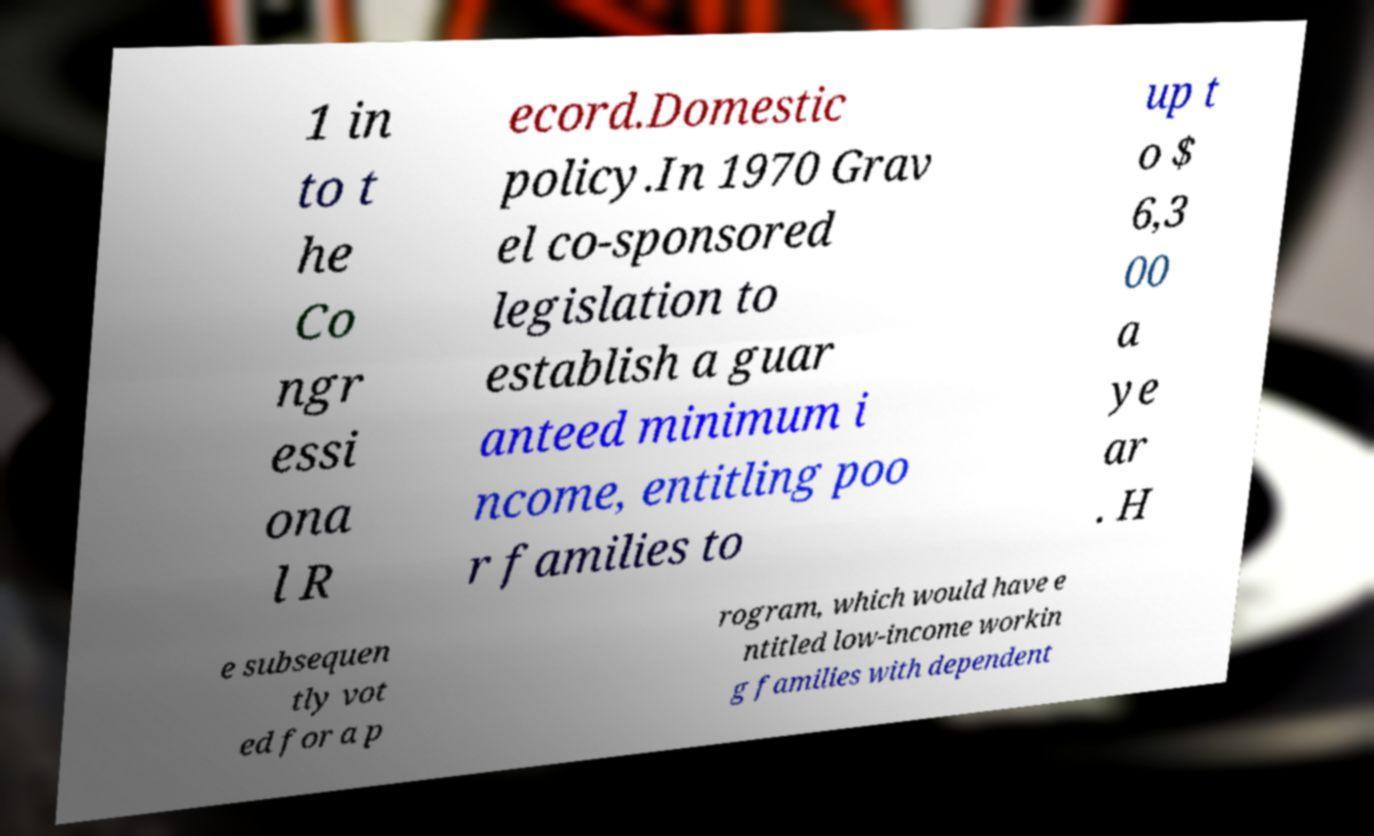Can you accurately transcribe the text from the provided image for me? 1 in to t he Co ngr essi ona l R ecord.Domestic policy.In 1970 Grav el co-sponsored legislation to establish a guar anteed minimum i ncome, entitling poo r families to up t o $ 6,3 00 a ye ar . H e subsequen tly vot ed for a p rogram, which would have e ntitled low-income workin g families with dependent 